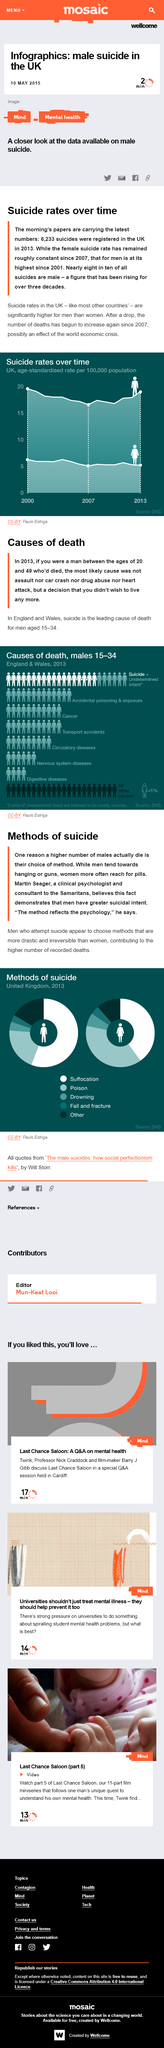Outline some significant characteristics in this image. The leading cause of death among males aged 15-34 was suicide. In 2013, suffocation was the most commonly used method of suicide among men in the United Kingdom. According to the information provided, the two leading causes of death, excluding suicide, are accidental poisoning and exposure, and cancer. It is commonly observed that men tend to choose hanging or guns as the method of committing suicide. Suicide is a leading cause of death worldwide, and the choice of suicide method is one of the reasons why more males die than females from suicide, according to research. 